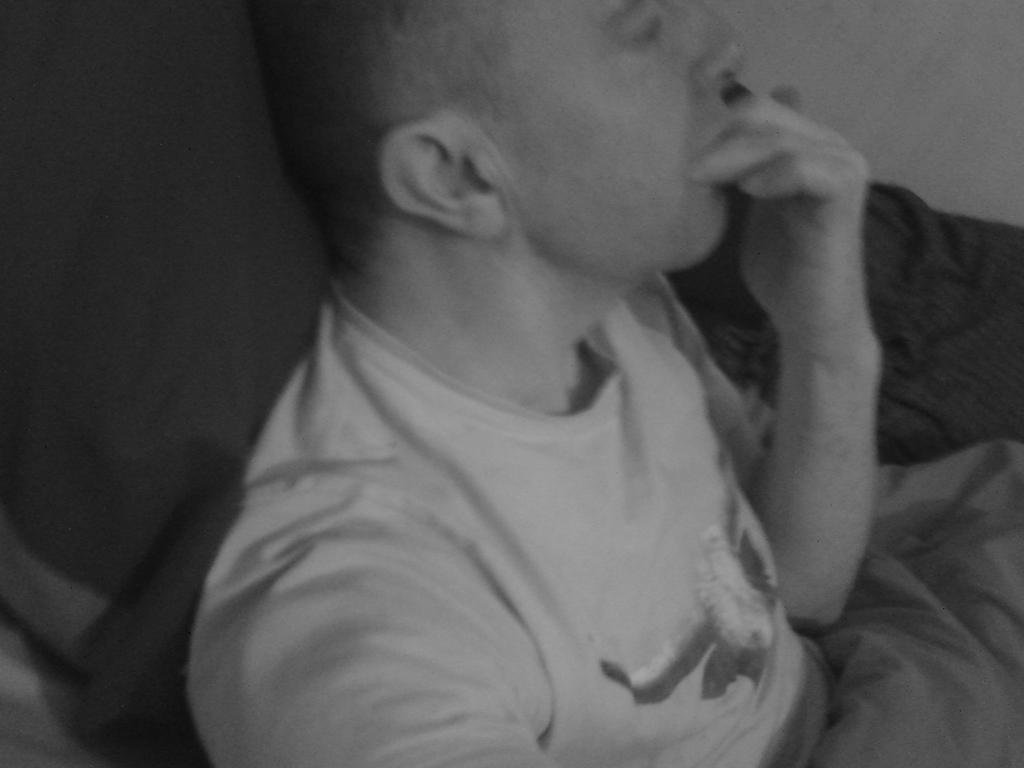What is the main subject of the image? There is a man in the image. What is the man wearing? The man is wearing a white t-shirt. Is there anything covering the man in the image? Yes, there is a blanket on the man. What color is the left corner of the image? The left corner of the image is black. Where is the shelf located in the image? There is no shelf present in the image. What color is the crayon being used by the man in the image? There is no crayon or any drawing activity depicted in the image. 